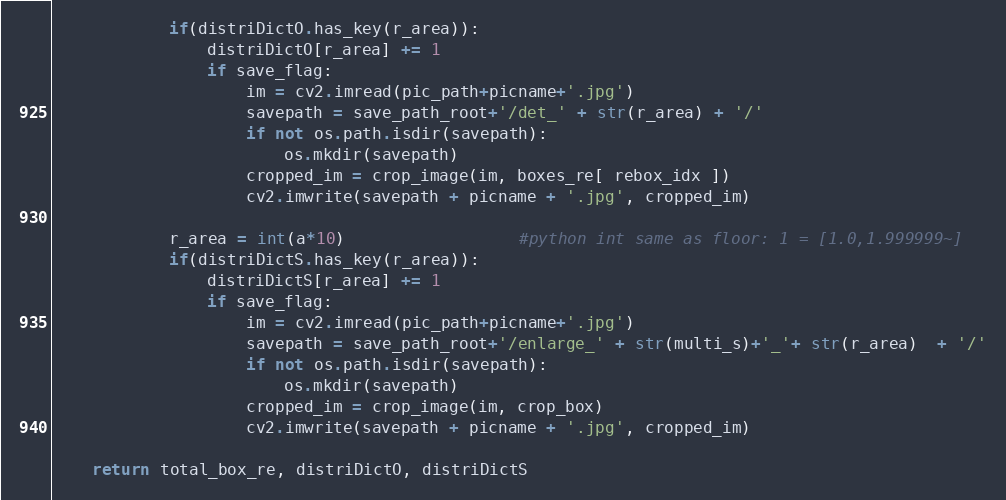Convert code to text. <code><loc_0><loc_0><loc_500><loc_500><_Python_>            if(distriDictO.has_key(r_area)):
                distriDictO[r_area] += 1
                if save_flag:
                    im = cv2.imread(pic_path+picname+'.jpg')
                    savepath = save_path_root+'/det_' + str(r_area) + '/'
                    if not os.path.isdir(savepath):
                        os.mkdir(savepath)
                    cropped_im = crop_image(im, boxes_re[ rebox_idx ])
                    cv2.imwrite(savepath + picname + '.jpg', cropped_im)
        
            r_area = int(a*10)                  #python int same as floor: 1 = [1.0,1.999999~]
            if(distriDictS.has_key(r_area)):
                distriDictS[r_area] += 1
                if save_flag:
                    im = cv2.imread(pic_path+picname+'.jpg')
                    savepath = save_path_root+'/enlarge_' + str(multi_s)+'_'+ str(r_area)  + '/'
                    if not os.path.isdir(savepath):
                        os.mkdir(savepath)
                    cropped_im = crop_image(im, crop_box)
                    cv2.imwrite(savepath + picname + '.jpg', cropped_im)

    return total_box_re, distriDictO, distriDictS


</code> 